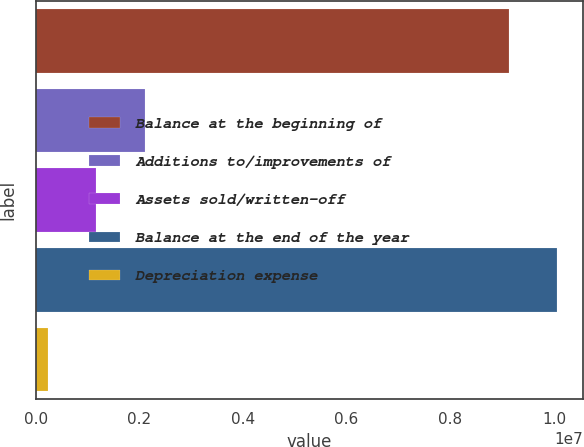Convert chart to OTSL. <chart><loc_0><loc_0><loc_500><loc_500><bar_chart><fcel>Balance at the beginning of<fcel>Additions to/improvements of<fcel>Assets sold/written-off<fcel>Balance at the end of the year<fcel>Depreciation expense<nl><fcel>9.12681e+06<fcel>2.10321e+06<fcel>1.17004e+06<fcel>1.006e+07<fcel>236883<nl></chart> 